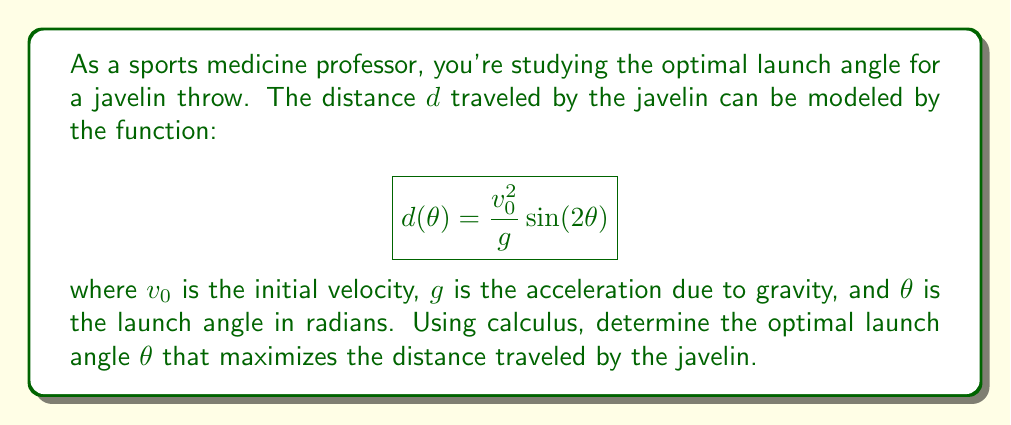Solve this math problem. To find the optimal launch angle, we need to find the maximum of the function $d(\theta)$. This can be done by taking the derivative of $d(\theta)$ with respect to $\theta$, setting it equal to zero, and solving for $\theta$.

1) First, let's take the derivative of $d(\theta)$ with respect to $\theta$:

   $$d'(\theta) = \frac{v_0^2}{g} \cdot 2\cos(2\theta)$$

2) Now, set this equal to zero and solve for $\theta$:

   $$\frac{v_0^2}{g} \cdot 2\cos(2\theta) = 0$$

3) Since $\frac{v_0^2}{g}$ is always positive (assuming $v_0 \neq 0$), we can simplify:

   $$\cos(2\theta) = 0$$

4) We know that cosine equals zero when its argument is $\frac{\pi}{2}$ or $\frac{3\pi}{2}$. So:

   $$2\theta = \frac{\pi}{2}$$ or $$2\theta = \frac{3\pi}{2}$$

5) Solving for $\theta$:

   $$\theta = \frac{\pi}{4}$$ or $$\theta = \frac{3\pi}{4}$$

6) To determine which of these is the maximum (rather than the minimum), we can check the second derivative or simply observe that $\frac{\pi}{4}$ (45°) is the standard result for this problem.

Therefore, the optimal launch angle is $\frac{\pi}{4}$ radians or 45°.
Answer: $\frac{\pi}{4}$ radians (45°) 